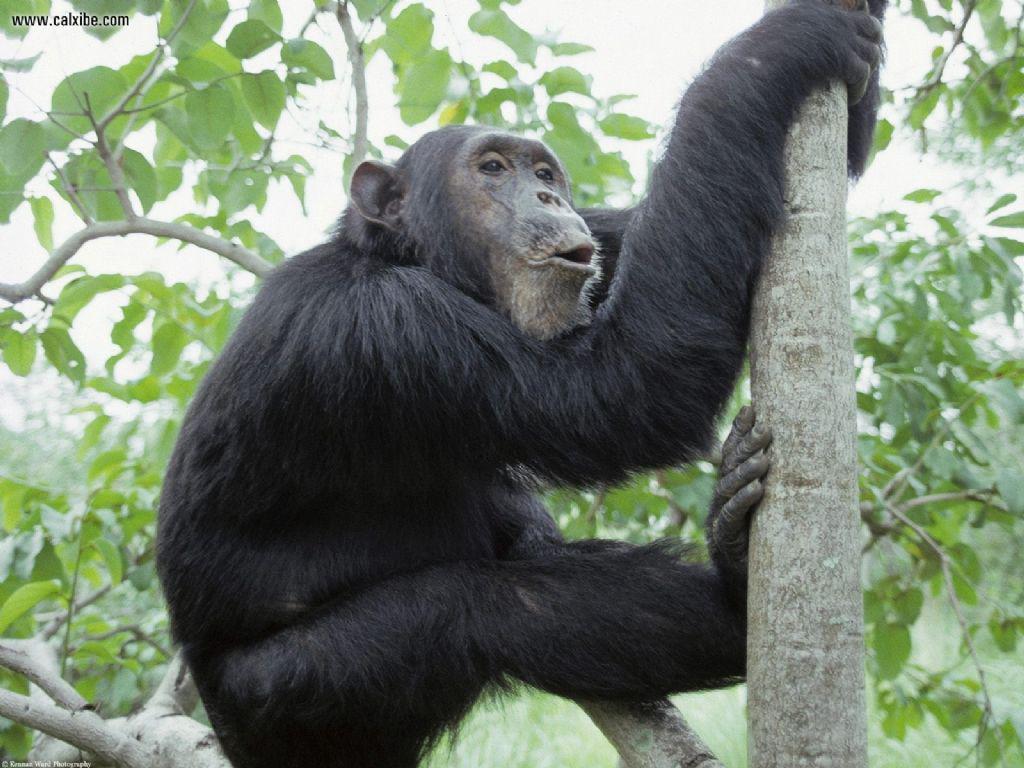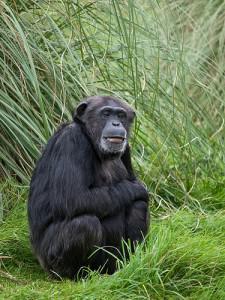The first image is the image on the left, the second image is the image on the right. For the images shown, is this caption "There is exactly one animal in the image on the left." true? Answer yes or no. Yes. 